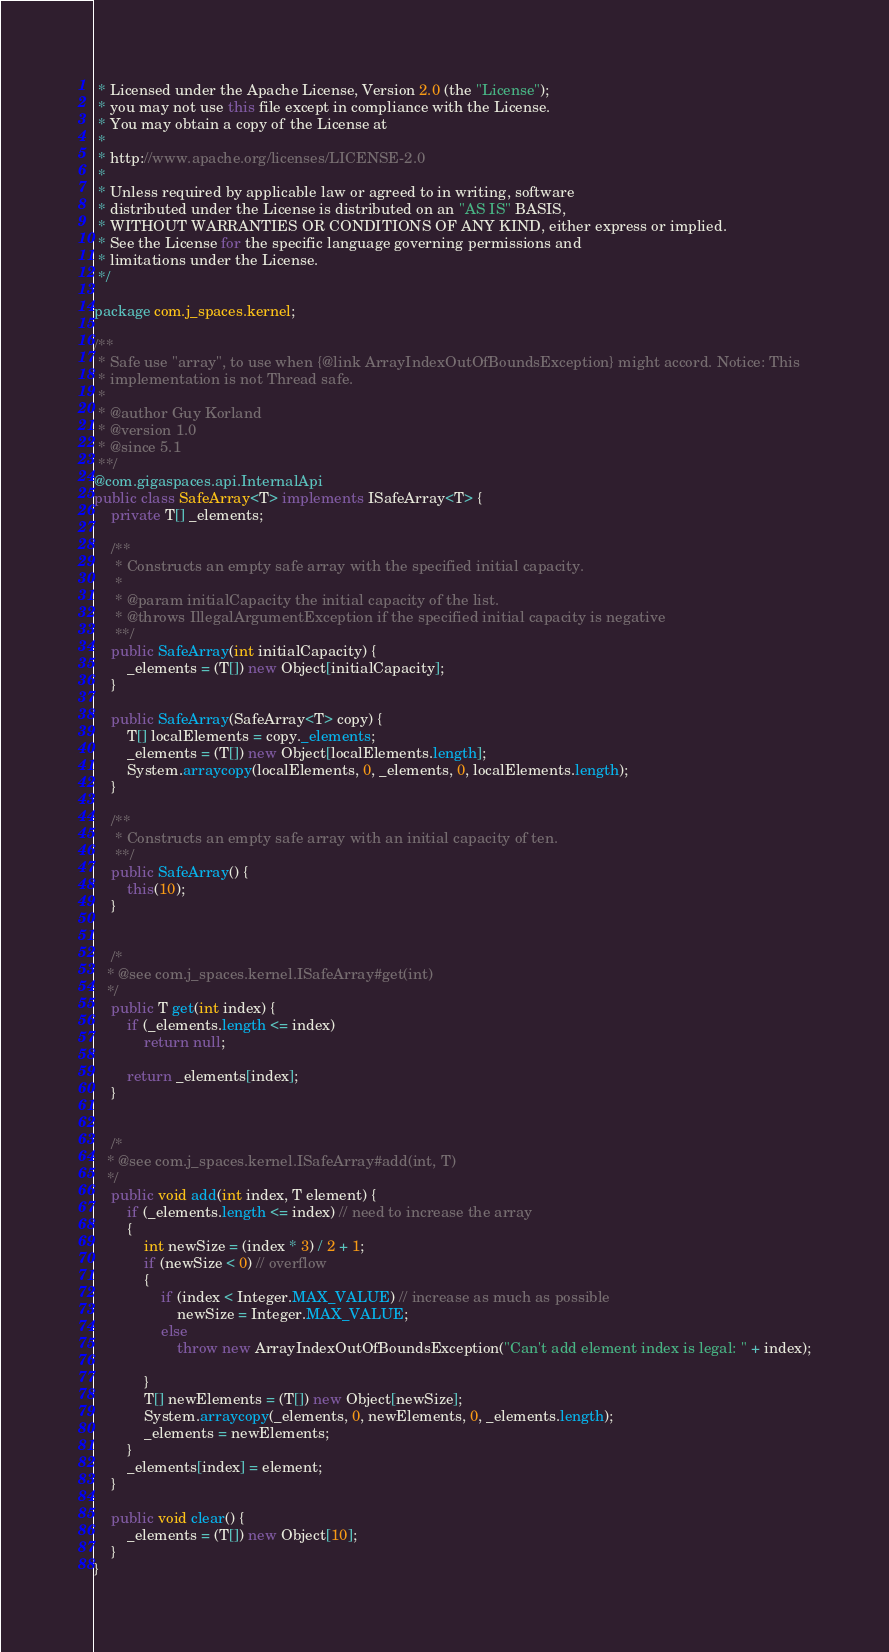<code> <loc_0><loc_0><loc_500><loc_500><_Java_> * Licensed under the Apache License, Version 2.0 (the "License");
 * you may not use this file except in compliance with the License.
 * You may obtain a copy of the License at
 *
 * http://www.apache.org/licenses/LICENSE-2.0
 *
 * Unless required by applicable law or agreed to in writing, software
 * distributed under the License is distributed on an "AS IS" BASIS,
 * WITHOUT WARRANTIES OR CONDITIONS OF ANY KIND, either express or implied.
 * See the License for the specific language governing permissions and
 * limitations under the License.
 */

package com.j_spaces.kernel;

/**
 * Safe use "array", to use when {@link ArrayIndexOutOfBoundsException} might accord. Notice: This
 * implementation is not Thread safe.
 *
 * @author Guy Korland
 * @version 1.0
 * @since 5.1
 **/
@com.gigaspaces.api.InternalApi
public class SafeArray<T> implements ISafeArray<T> {
    private T[] _elements;

    /**
     * Constructs an empty safe array with the specified initial capacity.
     *
     * @param initialCapacity the initial capacity of the list.
     * @throws IllegalArgumentException if the specified initial capacity is negative
     **/
    public SafeArray(int initialCapacity) {
        _elements = (T[]) new Object[initialCapacity];
    }

    public SafeArray(SafeArray<T> copy) {
        T[] localElements = copy._elements;
        _elements = (T[]) new Object[localElements.length];
        System.arraycopy(localElements, 0, _elements, 0, localElements.length);
    }

    /**
     * Constructs an empty safe array with an initial capacity of ten.
     **/
    public SafeArray() {
        this(10);
    }


    /*
   * @see com.j_spaces.kernel.ISafeArray#get(int)
   */
    public T get(int index) {
        if (_elements.length <= index)
            return null;

        return _elements[index];
    }


    /*
   * @see com.j_spaces.kernel.ISafeArray#add(int, T)
   */
    public void add(int index, T element) {
        if (_elements.length <= index) // need to increase the array
        {
            int newSize = (index * 3) / 2 + 1;
            if (newSize < 0) // overflow
            {
                if (index < Integer.MAX_VALUE) // increase as much as possible
                    newSize = Integer.MAX_VALUE;
                else
                    throw new ArrayIndexOutOfBoundsException("Can't add element index is legal: " + index);

            }
            T[] newElements = (T[]) new Object[newSize];
            System.arraycopy(_elements, 0, newElements, 0, _elements.length);
            _elements = newElements;
        }
        _elements[index] = element;
    }

    public void clear() {
        _elements = (T[]) new Object[10];
    }
}
</code> 